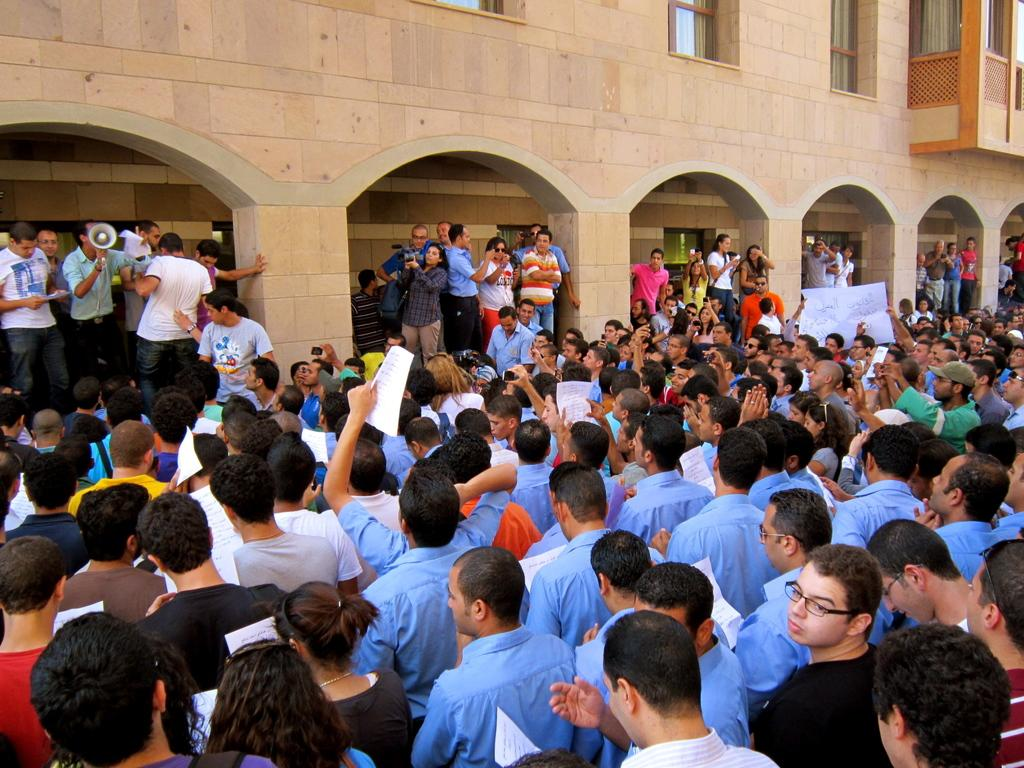What are the people in the image doing? The people in the image are standing and holding papers. What can be seen in the background of the image? There is a building in the image. Is there any specific object being held by one of the people? Yes, a person is holding a mouth speaker. How many hens are visible in the image? There are no hens present in the image. What type of army is depicted in the image? There is no army depicted in the image. 